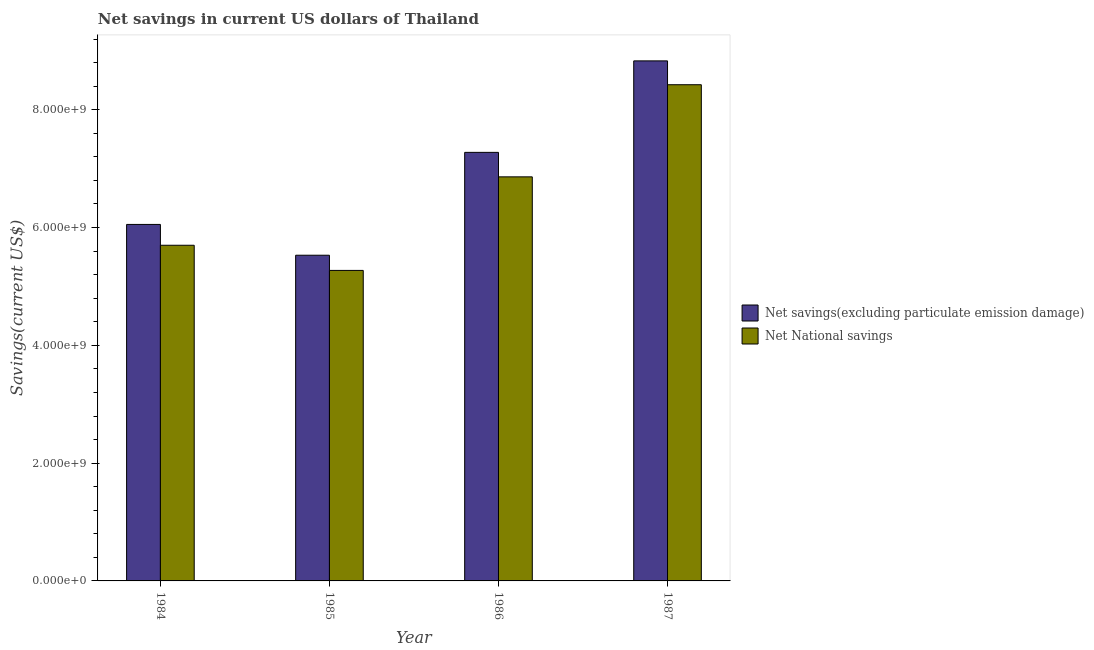How many groups of bars are there?
Provide a succinct answer. 4. Are the number of bars per tick equal to the number of legend labels?
Make the answer very short. Yes. Are the number of bars on each tick of the X-axis equal?
Give a very brief answer. Yes. How many bars are there on the 2nd tick from the left?
Your answer should be very brief. 2. In how many cases, is the number of bars for a given year not equal to the number of legend labels?
Provide a succinct answer. 0. What is the net national savings in 1986?
Offer a terse response. 6.86e+09. Across all years, what is the maximum net savings(excluding particulate emission damage)?
Offer a terse response. 8.83e+09. Across all years, what is the minimum net savings(excluding particulate emission damage)?
Make the answer very short. 5.53e+09. What is the total net national savings in the graph?
Your answer should be very brief. 2.63e+1. What is the difference between the net savings(excluding particulate emission damage) in 1984 and that in 1985?
Provide a short and direct response. 5.23e+08. What is the difference between the net national savings in 1986 and the net savings(excluding particulate emission damage) in 1987?
Offer a very short reply. -1.56e+09. What is the average net national savings per year?
Give a very brief answer. 6.56e+09. In the year 1987, what is the difference between the net savings(excluding particulate emission damage) and net national savings?
Your response must be concise. 0. What is the ratio of the net savings(excluding particulate emission damage) in 1985 to that in 1986?
Ensure brevity in your answer.  0.76. What is the difference between the highest and the second highest net national savings?
Your response must be concise. 1.56e+09. What is the difference between the highest and the lowest net national savings?
Your answer should be compact. 3.15e+09. In how many years, is the net savings(excluding particulate emission damage) greater than the average net savings(excluding particulate emission damage) taken over all years?
Give a very brief answer. 2. What does the 1st bar from the left in 1985 represents?
Offer a very short reply. Net savings(excluding particulate emission damage). What does the 1st bar from the right in 1987 represents?
Give a very brief answer. Net National savings. How many years are there in the graph?
Make the answer very short. 4. What is the difference between two consecutive major ticks on the Y-axis?
Make the answer very short. 2.00e+09. Does the graph contain any zero values?
Your answer should be compact. No. Where does the legend appear in the graph?
Your response must be concise. Center right. How many legend labels are there?
Provide a short and direct response. 2. What is the title of the graph?
Your response must be concise. Net savings in current US dollars of Thailand. What is the label or title of the X-axis?
Give a very brief answer. Year. What is the label or title of the Y-axis?
Your answer should be compact. Savings(current US$). What is the Savings(current US$) in Net savings(excluding particulate emission damage) in 1984?
Your answer should be compact. 6.05e+09. What is the Savings(current US$) of Net National savings in 1984?
Ensure brevity in your answer.  5.70e+09. What is the Savings(current US$) in Net savings(excluding particulate emission damage) in 1985?
Offer a terse response. 5.53e+09. What is the Savings(current US$) of Net National savings in 1985?
Your answer should be compact. 5.27e+09. What is the Savings(current US$) in Net savings(excluding particulate emission damage) in 1986?
Your answer should be very brief. 7.28e+09. What is the Savings(current US$) of Net National savings in 1986?
Ensure brevity in your answer.  6.86e+09. What is the Savings(current US$) in Net savings(excluding particulate emission damage) in 1987?
Give a very brief answer. 8.83e+09. What is the Savings(current US$) of Net National savings in 1987?
Ensure brevity in your answer.  8.42e+09. Across all years, what is the maximum Savings(current US$) in Net savings(excluding particulate emission damage)?
Give a very brief answer. 8.83e+09. Across all years, what is the maximum Savings(current US$) of Net National savings?
Keep it short and to the point. 8.42e+09. Across all years, what is the minimum Savings(current US$) in Net savings(excluding particulate emission damage)?
Provide a short and direct response. 5.53e+09. Across all years, what is the minimum Savings(current US$) in Net National savings?
Your answer should be very brief. 5.27e+09. What is the total Savings(current US$) in Net savings(excluding particulate emission damage) in the graph?
Your answer should be compact. 2.77e+1. What is the total Savings(current US$) of Net National savings in the graph?
Provide a succinct answer. 2.63e+1. What is the difference between the Savings(current US$) in Net savings(excluding particulate emission damage) in 1984 and that in 1985?
Offer a very short reply. 5.23e+08. What is the difference between the Savings(current US$) of Net National savings in 1984 and that in 1985?
Your response must be concise. 4.27e+08. What is the difference between the Savings(current US$) in Net savings(excluding particulate emission damage) in 1984 and that in 1986?
Keep it short and to the point. -1.22e+09. What is the difference between the Savings(current US$) of Net National savings in 1984 and that in 1986?
Provide a short and direct response. -1.16e+09. What is the difference between the Savings(current US$) in Net savings(excluding particulate emission damage) in 1984 and that in 1987?
Provide a short and direct response. -2.78e+09. What is the difference between the Savings(current US$) in Net National savings in 1984 and that in 1987?
Make the answer very short. -2.73e+09. What is the difference between the Savings(current US$) in Net savings(excluding particulate emission damage) in 1985 and that in 1986?
Offer a terse response. -1.75e+09. What is the difference between the Savings(current US$) in Net National savings in 1985 and that in 1986?
Your answer should be compact. -1.59e+09. What is the difference between the Savings(current US$) of Net savings(excluding particulate emission damage) in 1985 and that in 1987?
Offer a terse response. -3.30e+09. What is the difference between the Savings(current US$) in Net National savings in 1985 and that in 1987?
Give a very brief answer. -3.15e+09. What is the difference between the Savings(current US$) of Net savings(excluding particulate emission damage) in 1986 and that in 1987?
Make the answer very short. -1.55e+09. What is the difference between the Savings(current US$) of Net National savings in 1986 and that in 1987?
Your answer should be very brief. -1.56e+09. What is the difference between the Savings(current US$) in Net savings(excluding particulate emission damage) in 1984 and the Savings(current US$) in Net National savings in 1985?
Offer a very short reply. 7.81e+08. What is the difference between the Savings(current US$) in Net savings(excluding particulate emission damage) in 1984 and the Savings(current US$) in Net National savings in 1986?
Ensure brevity in your answer.  -8.08e+08. What is the difference between the Savings(current US$) of Net savings(excluding particulate emission damage) in 1984 and the Savings(current US$) of Net National savings in 1987?
Ensure brevity in your answer.  -2.37e+09. What is the difference between the Savings(current US$) in Net savings(excluding particulate emission damage) in 1985 and the Savings(current US$) in Net National savings in 1986?
Provide a succinct answer. -1.33e+09. What is the difference between the Savings(current US$) in Net savings(excluding particulate emission damage) in 1985 and the Savings(current US$) in Net National savings in 1987?
Ensure brevity in your answer.  -2.90e+09. What is the difference between the Savings(current US$) of Net savings(excluding particulate emission damage) in 1986 and the Savings(current US$) of Net National savings in 1987?
Your answer should be very brief. -1.15e+09. What is the average Savings(current US$) in Net savings(excluding particulate emission damage) per year?
Make the answer very short. 6.92e+09. What is the average Savings(current US$) of Net National savings per year?
Provide a short and direct response. 6.56e+09. In the year 1984, what is the difference between the Savings(current US$) of Net savings(excluding particulate emission damage) and Savings(current US$) of Net National savings?
Your response must be concise. 3.54e+08. In the year 1985, what is the difference between the Savings(current US$) of Net savings(excluding particulate emission damage) and Savings(current US$) of Net National savings?
Make the answer very short. 2.58e+08. In the year 1986, what is the difference between the Savings(current US$) in Net savings(excluding particulate emission damage) and Savings(current US$) in Net National savings?
Your answer should be very brief. 4.16e+08. In the year 1987, what is the difference between the Savings(current US$) of Net savings(excluding particulate emission damage) and Savings(current US$) of Net National savings?
Your answer should be compact. 4.05e+08. What is the ratio of the Savings(current US$) of Net savings(excluding particulate emission damage) in 1984 to that in 1985?
Provide a short and direct response. 1.09. What is the ratio of the Savings(current US$) in Net National savings in 1984 to that in 1985?
Make the answer very short. 1.08. What is the ratio of the Savings(current US$) in Net savings(excluding particulate emission damage) in 1984 to that in 1986?
Ensure brevity in your answer.  0.83. What is the ratio of the Savings(current US$) in Net National savings in 1984 to that in 1986?
Provide a short and direct response. 0.83. What is the ratio of the Savings(current US$) in Net savings(excluding particulate emission damage) in 1984 to that in 1987?
Your answer should be compact. 0.69. What is the ratio of the Savings(current US$) of Net National savings in 1984 to that in 1987?
Ensure brevity in your answer.  0.68. What is the ratio of the Savings(current US$) in Net savings(excluding particulate emission damage) in 1985 to that in 1986?
Ensure brevity in your answer.  0.76. What is the ratio of the Savings(current US$) of Net National savings in 1985 to that in 1986?
Give a very brief answer. 0.77. What is the ratio of the Savings(current US$) in Net savings(excluding particulate emission damage) in 1985 to that in 1987?
Offer a very short reply. 0.63. What is the ratio of the Savings(current US$) of Net National savings in 1985 to that in 1987?
Provide a succinct answer. 0.63. What is the ratio of the Savings(current US$) of Net savings(excluding particulate emission damage) in 1986 to that in 1987?
Your answer should be very brief. 0.82. What is the ratio of the Savings(current US$) in Net National savings in 1986 to that in 1987?
Offer a very short reply. 0.81. What is the difference between the highest and the second highest Savings(current US$) in Net savings(excluding particulate emission damage)?
Your response must be concise. 1.55e+09. What is the difference between the highest and the second highest Savings(current US$) of Net National savings?
Your answer should be very brief. 1.56e+09. What is the difference between the highest and the lowest Savings(current US$) in Net savings(excluding particulate emission damage)?
Provide a succinct answer. 3.30e+09. What is the difference between the highest and the lowest Savings(current US$) of Net National savings?
Offer a very short reply. 3.15e+09. 